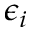Convert formula to latex. <formula><loc_0><loc_0><loc_500><loc_500>\epsilon _ { i }</formula> 